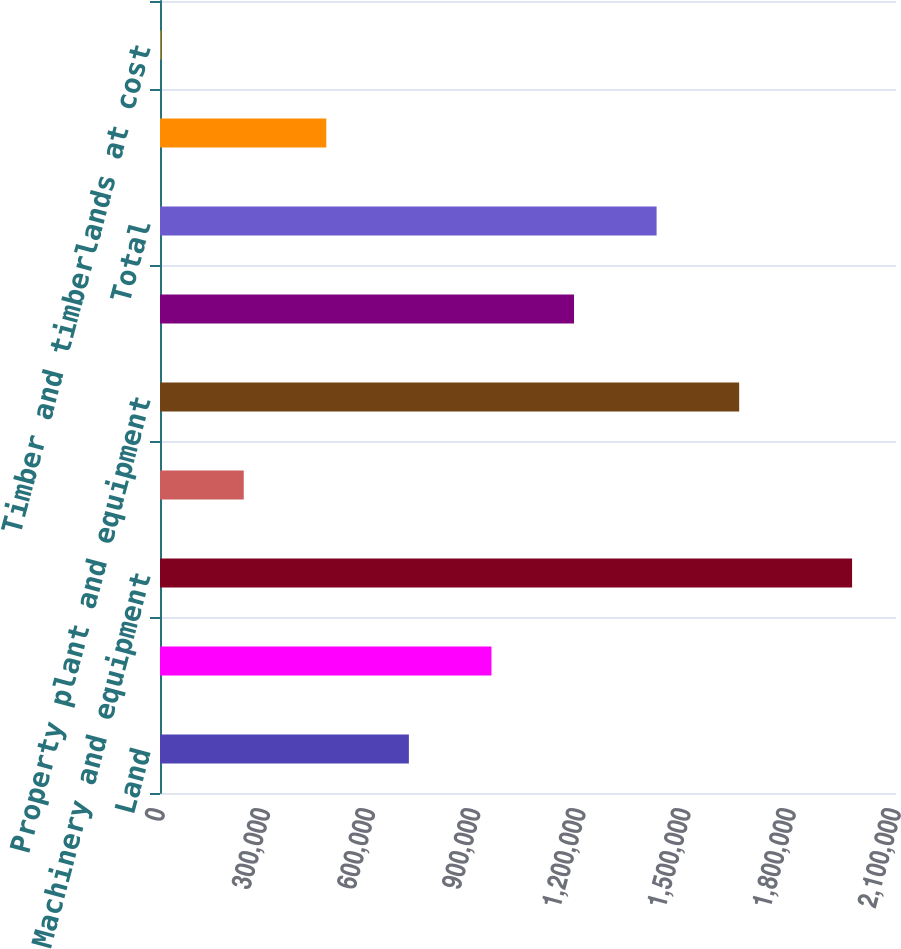Convert chart to OTSL. <chart><loc_0><loc_0><loc_500><loc_500><bar_chart><fcel>Land<fcel>Buildings<fcel>Machinery and equipment<fcel>Other<fcel>Property plant and equipment<fcel>Less Accumulated depreciation<fcel>Total<fcel>Construction in progress<fcel>Timber and timberlands at cost<nl><fcel>710129<fcel>945726<fcel>1.97468e+06<fcel>238936<fcel>1.65252e+06<fcel>1.18132e+06<fcel>1.41692e+06<fcel>474532<fcel>3339<nl></chart> 